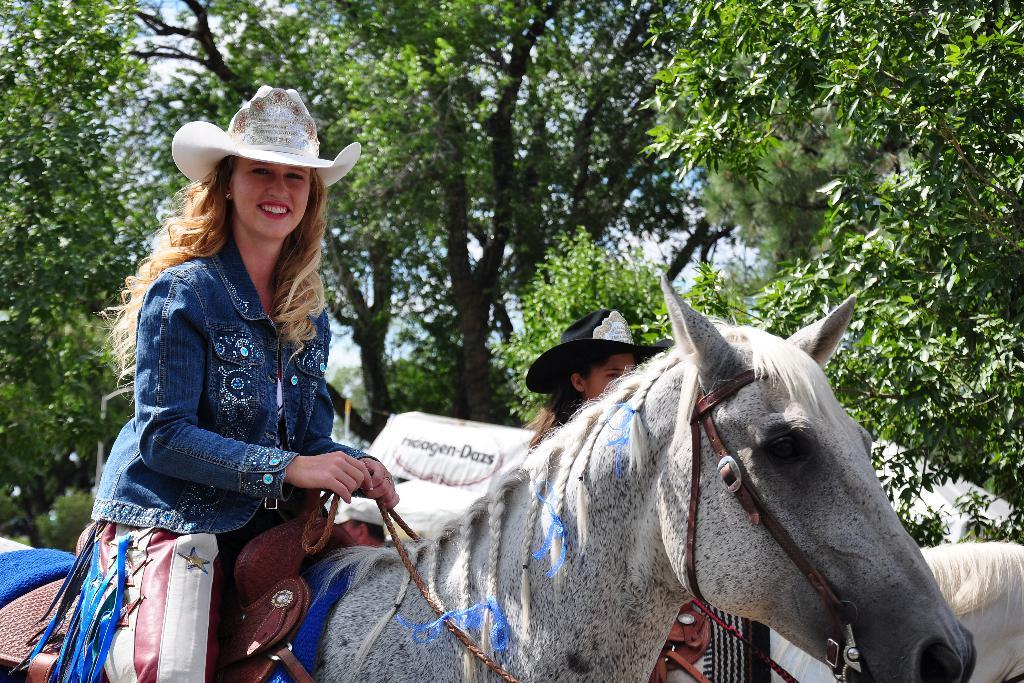How many women are in the image? There are two women in the image. What are the women wearing on their heads? The women are wearing caps. What are the women holding in their hands? The women are holding ropes in their hands. What are the women sitting on? The women are sitting on horses. What is the facial expression of one of the women? One of the women is smiling. What can be seen in the background of the image? There are trees visible in the background of the image. What type of pump is visible in the image? There is no pump present in the image. What religious symbols can be seen in the image? There are no religious symbols present in the image. 